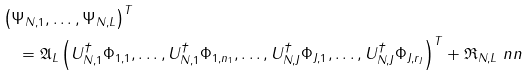Convert formula to latex. <formula><loc_0><loc_0><loc_500><loc_500>& \left ( \Psi _ { N , 1 } , \dots , \Psi _ { N , L } \right ) ^ { T } \\ & \quad = \mathfrak { A } _ { L } \left ( U _ { N , 1 } ^ { \dagger } \Phi _ { 1 , 1 } , \dots , U _ { N , 1 } ^ { \dagger } \Phi _ { 1 , n _ { 1 } } , \dots , U _ { N , J } ^ { \dagger } \Phi _ { J , 1 } , \dots , U _ { N , J } ^ { \dagger } \Phi _ { J , r _ { J } } \right ) ^ { T } + \mathfrak { R } _ { N , L } \ n n</formula> 